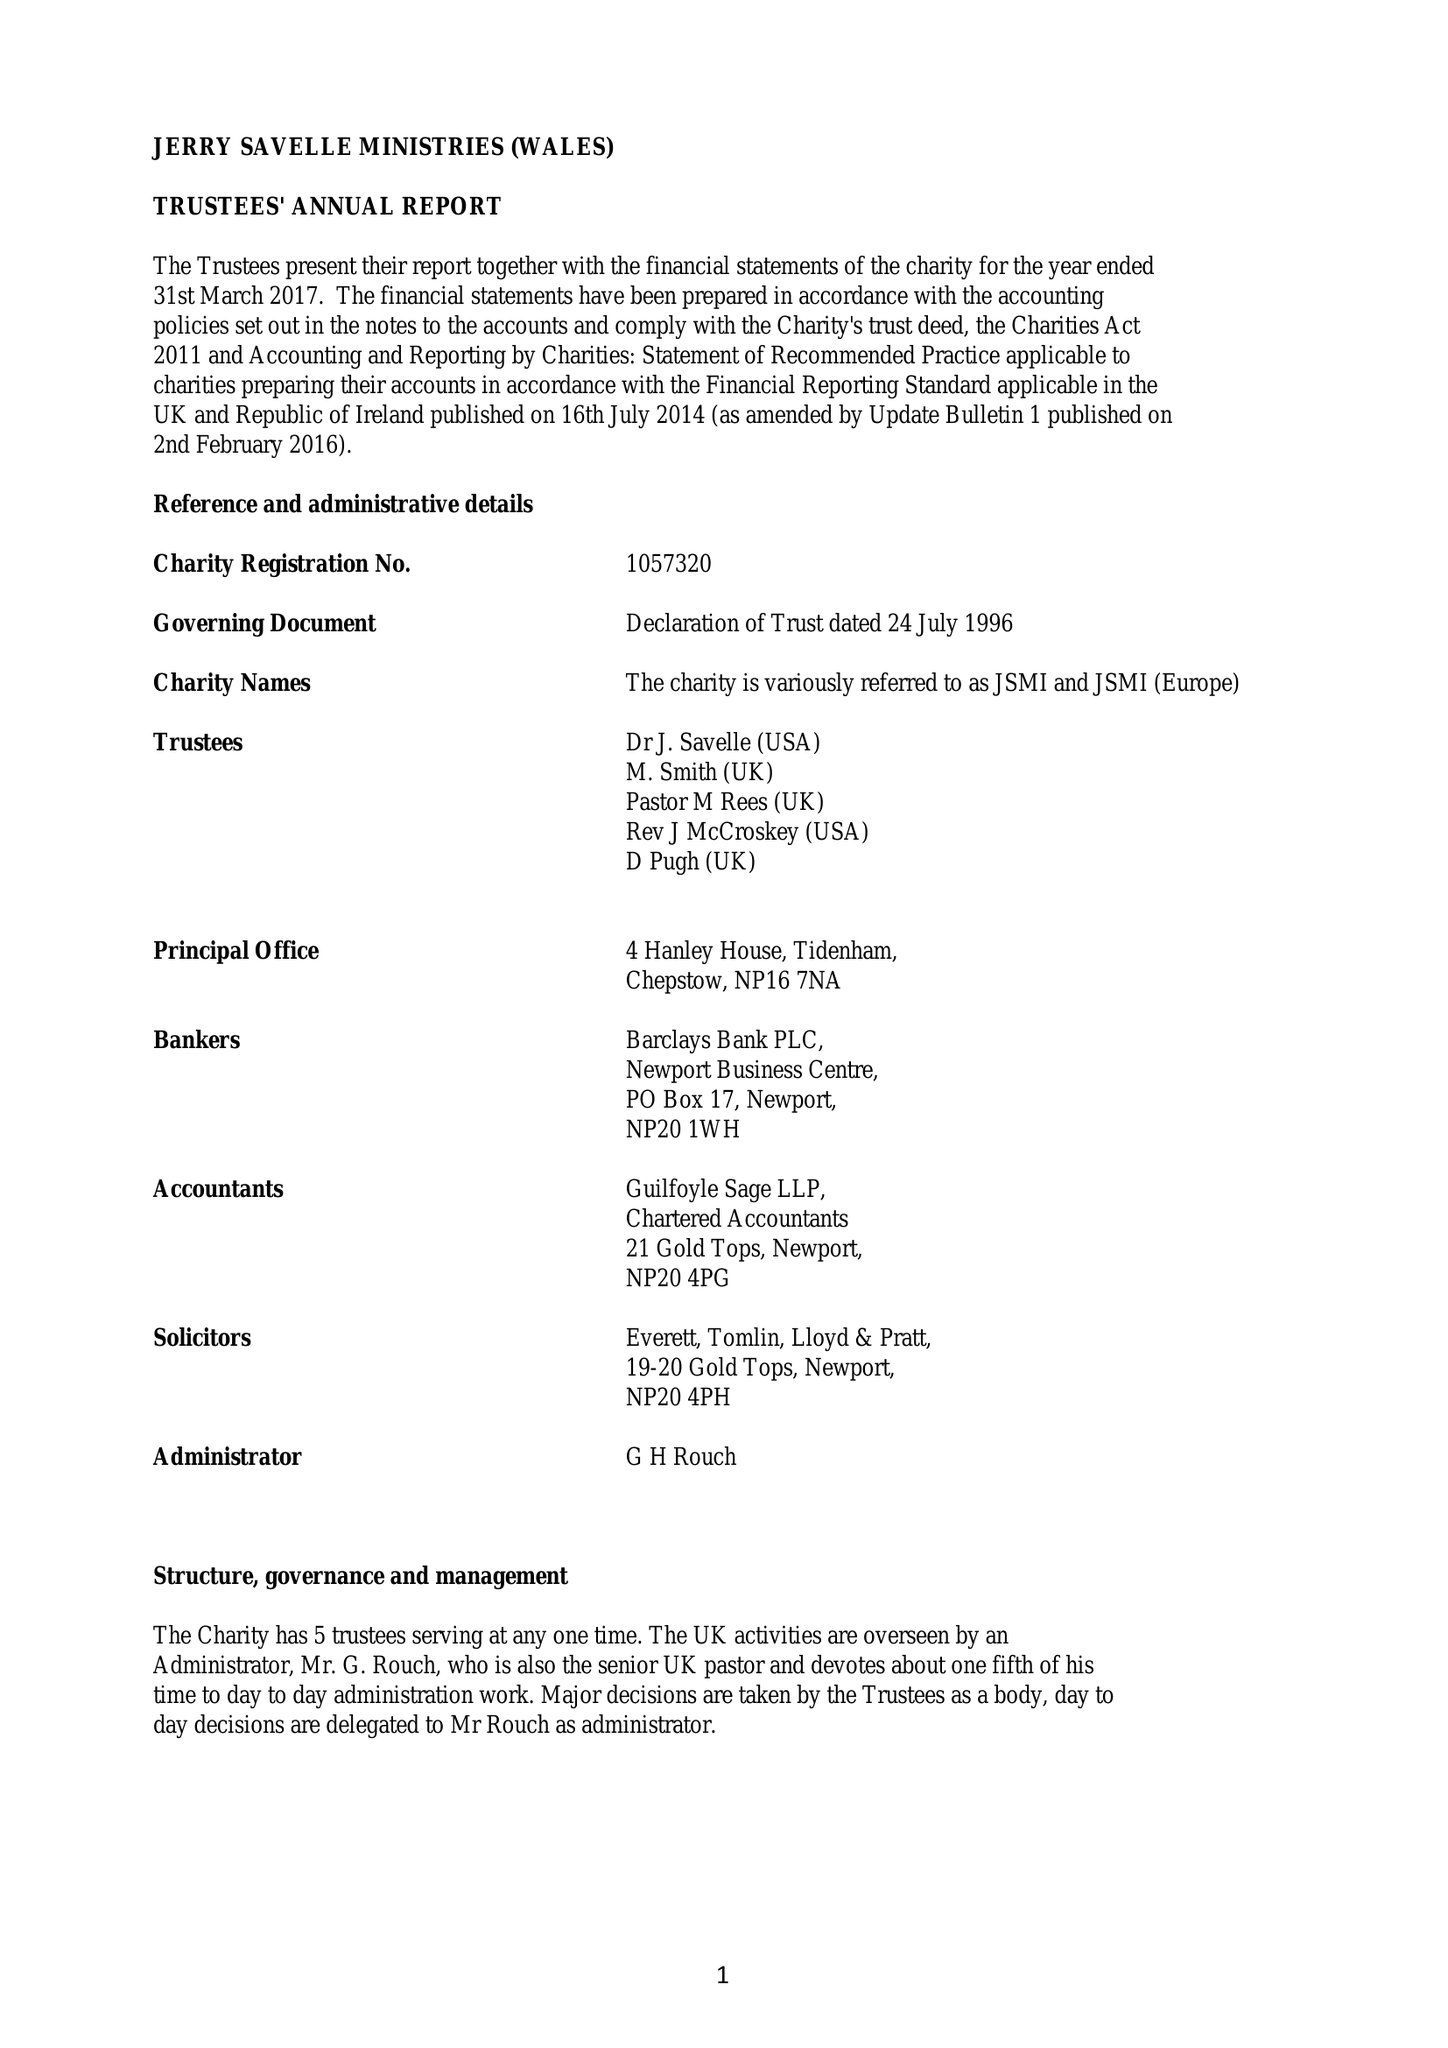What is the value for the charity_name?
Answer the question using a single word or phrase. Jerry Savelle Ministries (Wales) 